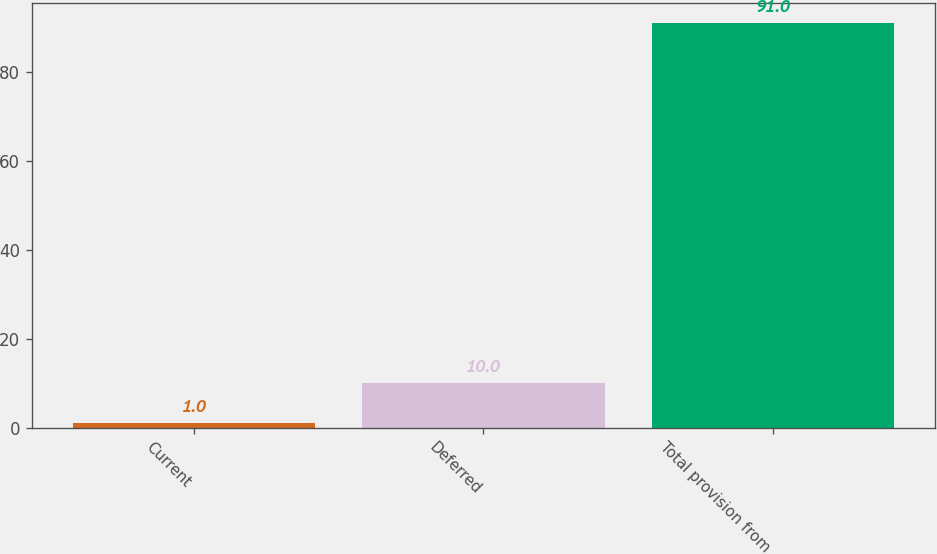Convert chart. <chart><loc_0><loc_0><loc_500><loc_500><bar_chart><fcel>Current<fcel>Deferred<fcel>Total provision from<nl><fcel>1<fcel>10<fcel>91<nl></chart> 